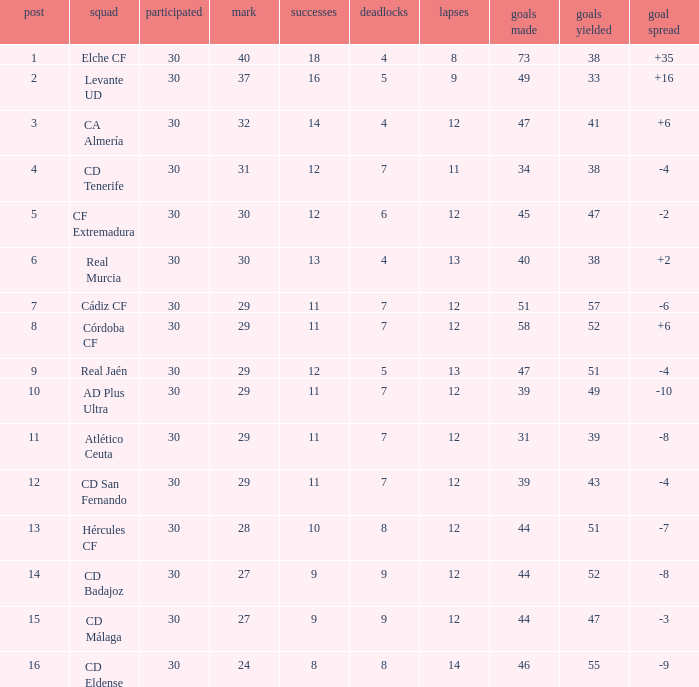What is the average number of goals against with more than 12 wins, 12 losses, and a position greater than 3? None. 